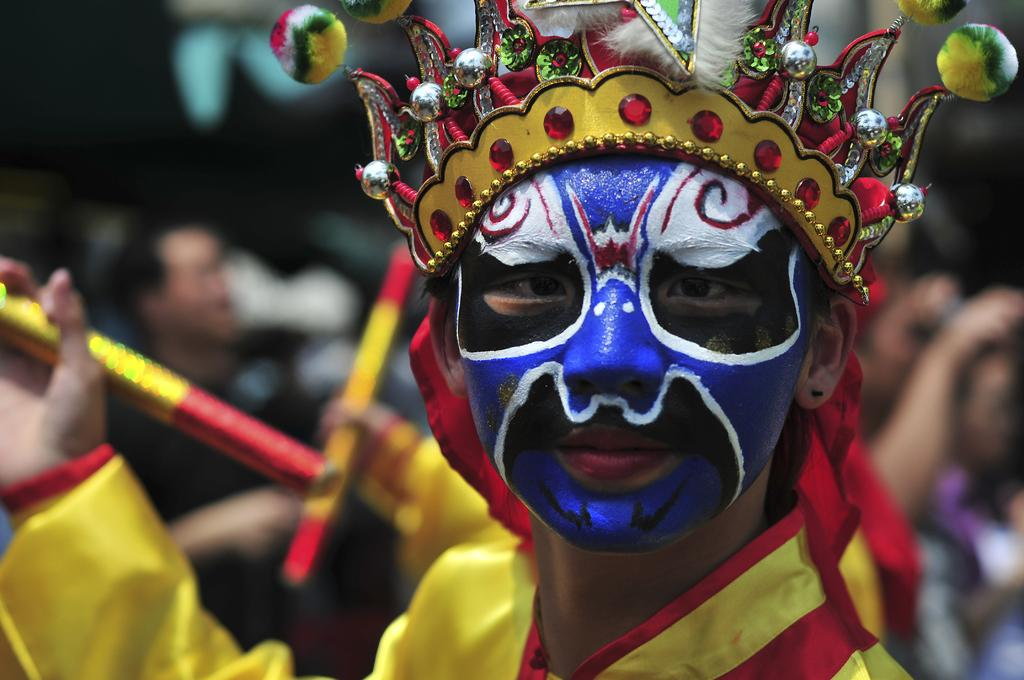Who or what is the main subject in the image? There is a person in the image. What is the person wearing? The person is wearing a yellow dress. Can you describe any additional features or accessories on the person? There is a painting on the person's face. How would you describe the background of the image? The background of the image is blurred. What type of drain is visible in the image? There is no drain present in the image. Can you hear the person speaking in the image? The image is a still photograph, so there is no sound or speech to hear. 